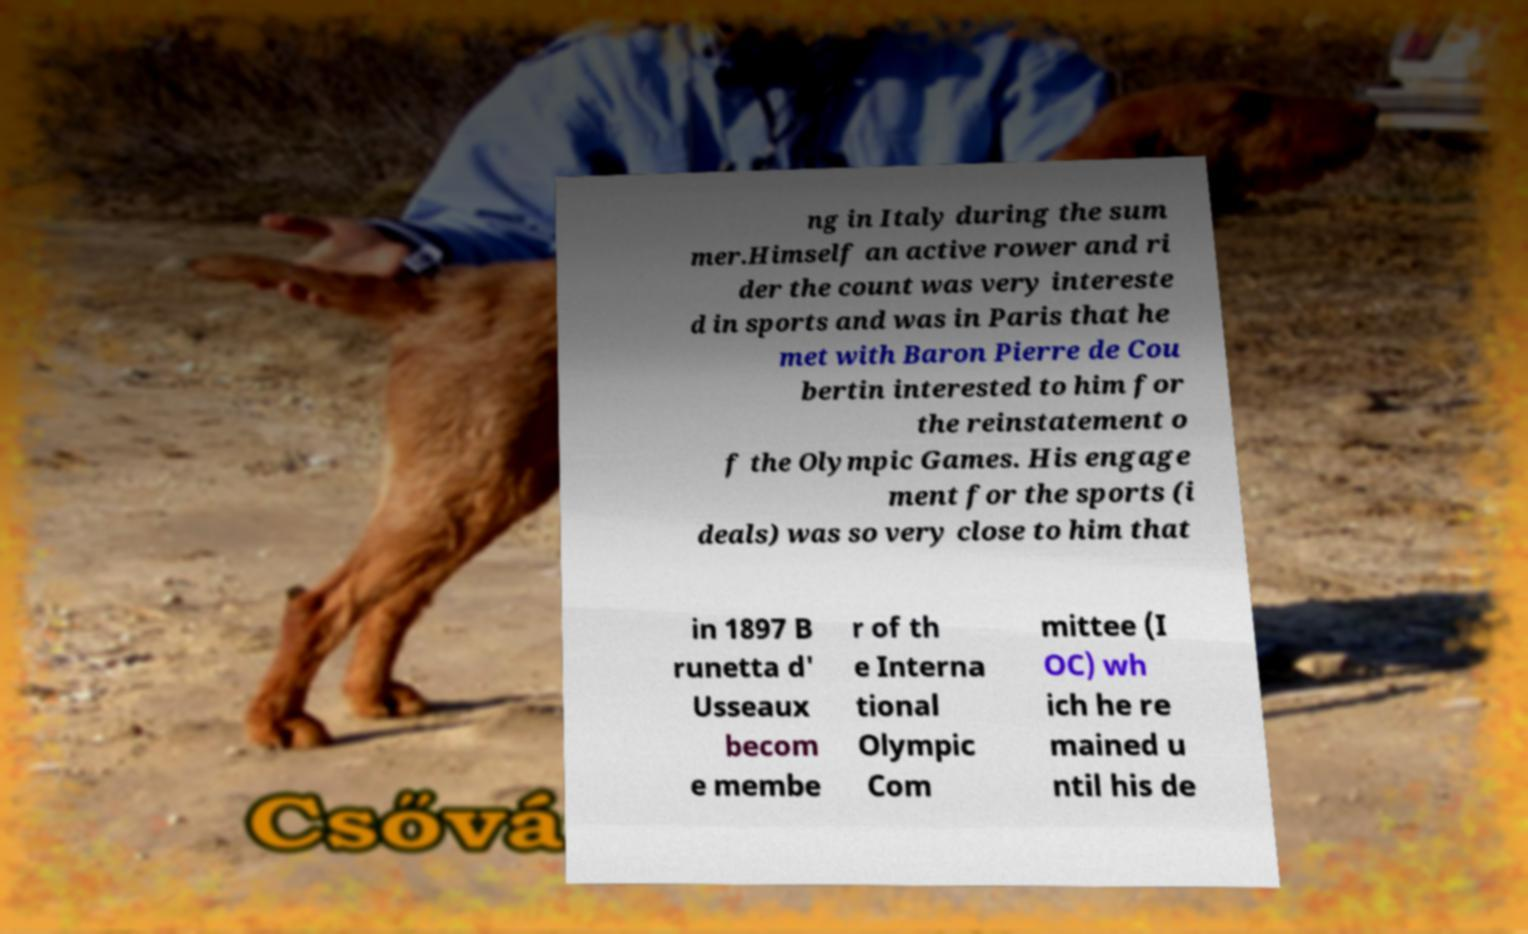I need the written content from this picture converted into text. Can you do that? ng in Italy during the sum mer.Himself an active rower and ri der the count was very intereste d in sports and was in Paris that he met with Baron Pierre de Cou bertin interested to him for the reinstatement o f the Olympic Games. His engage ment for the sports (i deals) was so very close to him that in 1897 B runetta d' Usseaux becom e membe r of th e Interna tional Olympic Com mittee (I OC) wh ich he re mained u ntil his de 